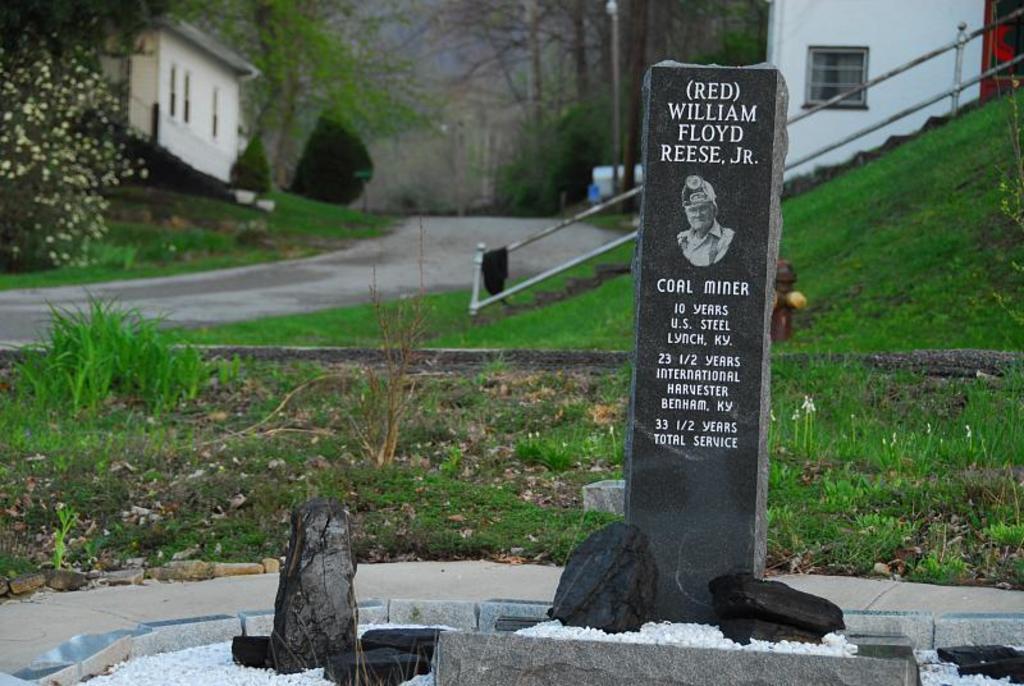Could you give a brief overview of what you see in this image? In this image I can see a tombstone which is black in color and in the background I can see some grass, the railing, few stairs, a fire hydrant and a plant. I can see the road, few trees, few buildings and the sky in the background. 